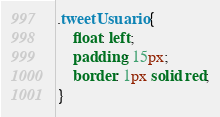<code> <loc_0><loc_0><loc_500><loc_500><_CSS_>
.tweetUsuario {
    float: left;
    padding: 15px;
    border: 1px solid red;
}
</code> 